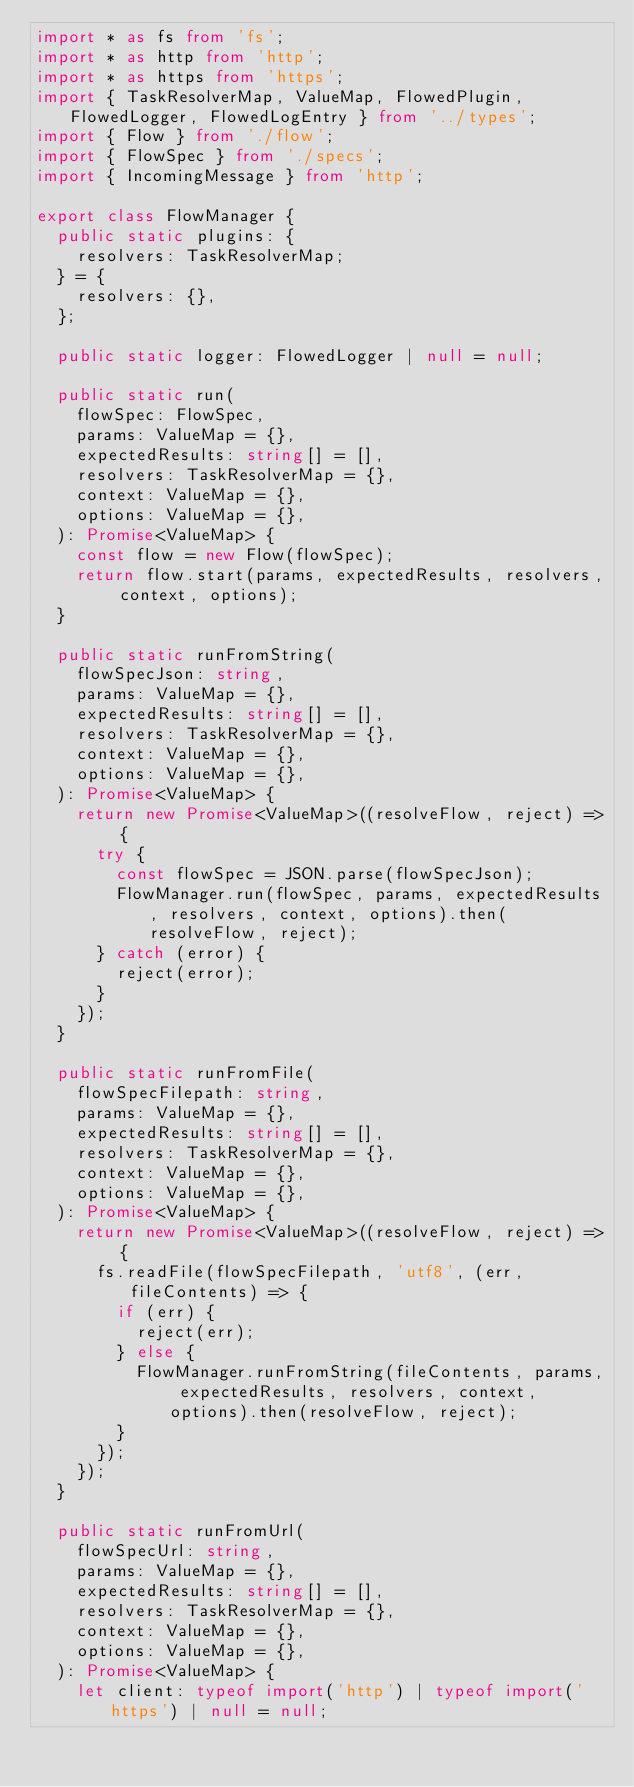<code> <loc_0><loc_0><loc_500><loc_500><_TypeScript_>import * as fs from 'fs';
import * as http from 'http';
import * as https from 'https';
import { TaskResolverMap, ValueMap, FlowedPlugin, FlowedLogger, FlowedLogEntry } from '../types';
import { Flow } from './flow';
import { FlowSpec } from './specs';
import { IncomingMessage } from 'http';

export class FlowManager {
  public static plugins: {
    resolvers: TaskResolverMap;
  } = {
    resolvers: {},
  };

  public static logger: FlowedLogger | null = null;

  public static run(
    flowSpec: FlowSpec,
    params: ValueMap = {},
    expectedResults: string[] = [],
    resolvers: TaskResolverMap = {},
    context: ValueMap = {},
    options: ValueMap = {},
  ): Promise<ValueMap> {
    const flow = new Flow(flowSpec);
    return flow.start(params, expectedResults, resolvers, context, options);
  }

  public static runFromString(
    flowSpecJson: string,
    params: ValueMap = {},
    expectedResults: string[] = [],
    resolvers: TaskResolverMap = {},
    context: ValueMap = {},
    options: ValueMap = {},
  ): Promise<ValueMap> {
    return new Promise<ValueMap>((resolveFlow, reject) => {
      try {
        const flowSpec = JSON.parse(flowSpecJson);
        FlowManager.run(flowSpec, params, expectedResults, resolvers, context, options).then(resolveFlow, reject);
      } catch (error) {
        reject(error);
      }
    });
  }

  public static runFromFile(
    flowSpecFilepath: string,
    params: ValueMap = {},
    expectedResults: string[] = [],
    resolvers: TaskResolverMap = {},
    context: ValueMap = {},
    options: ValueMap = {},
  ): Promise<ValueMap> {
    return new Promise<ValueMap>((resolveFlow, reject) => {
      fs.readFile(flowSpecFilepath, 'utf8', (err, fileContents) => {
        if (err) {
          reject(err);
        } else {
          FlowManager.runFromString(fileContents, params, expectedResults, resolvers, context, options).then(resolveFlow, reject);
        }
      });
    });
  }

  public static runFromUrl(
    flowSpecUrl: string,
    params: ValueMap = {},
    expectedResults: string[] = [],
    resolvers: TaskResolverMap = {},
    context: ValueMap = {},
    options: ValueMap = {},
  ): Promise<ValueMap> {
    let client: typeof import('http') | typeof import('https') | null = null;</code> 